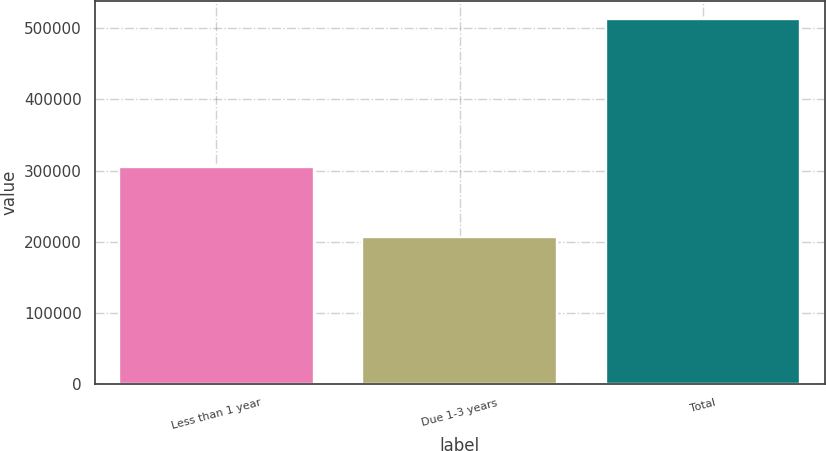Convert chart. <chart><loc_0><loc_0><loc_500><loc_500><bar_chart><fcel>Less than 1 year<fcel>Due 1-3 years<fcel>Total<nl><fcel>304699<fcel>207166<fcel>511865<nl></chart> 